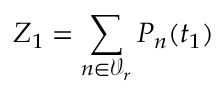Convert formula to latex. <formula><loc_0><loc_0><loc_500><loc_500>Z _ { 1 } = \sum _ { n \in \mathcal { V } _ { r } } P _ { n } ( t _ { 1 } )</formula> 